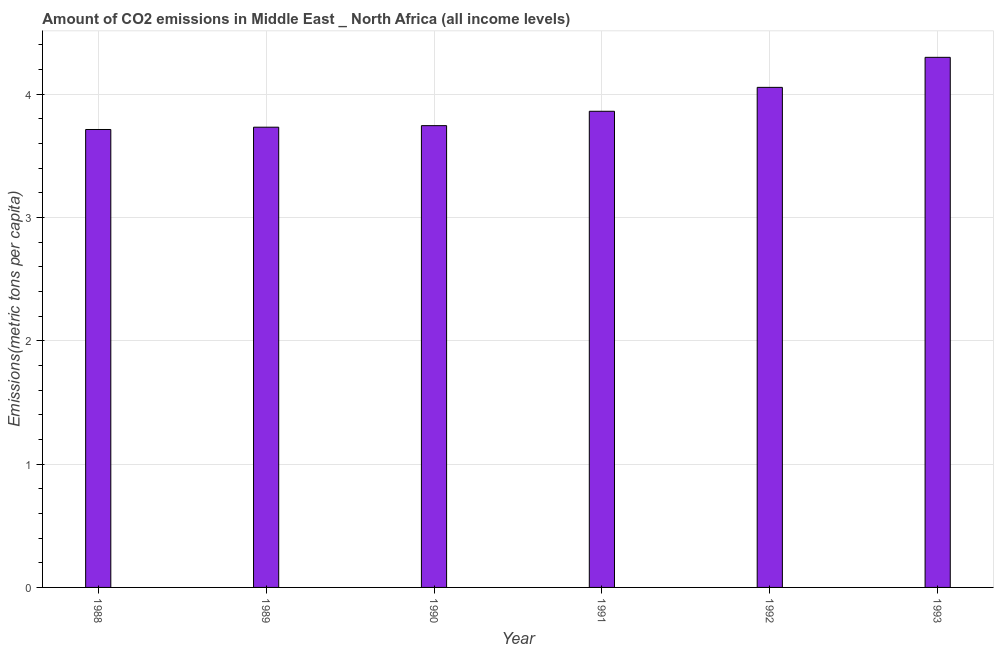Does the graph contain any zero values?
Your answer should be compact. No. Does the graph contain grids?
Make the answer very short. Yes. What is the title of the graph?
Provide a succinct answer. Amount of CO2 emissions in Middle East _ North Africa (all income levels). What is the label or title of the Y-axis?
Provide a succinct answer. Emissions(metric tons per capita). What is the amount of co2 emissions in 1990?
Provide a short and direct response. 3.74. Across all years, what is the maximum amount of co2 emissions?
Ensure brevity in your answer.  4.3. Across all years, what is the minimum amount of co2 emissions?
Offer a terse response. 3.71. What is the sum of the amount of co2 emissions?
Ensure brevity in your answer.  23.4. What is the difference between the amount of co2 emissions in 1988 and 1991?
Make the answer very short. -0.15. What is the average amount of co2 emissions per year?
Give a very brief answer. 3.9. What is the median amount of co2 emissions?
Your answer should be very brief. 3.8. In how many years, is the amount of co2 emissions greater than 1.8 metric tons per capita?
Offer a very short reply. 6. Do a majority of the years between 1990 and 1992 (inclusive) have amount of co2 emissions greater than 4 metric tons per capita?
Give a very brief answer. No. What is the ratio of the amount of co2 emissions in 1989 to that in 1991?
Give a very brief answer. 0.97. Is the amount of co2 emissions in 1988 less than that in 1989?
Ensure brevity in your answer.  Yes. What is the difference between the highest and the second highest amount of co2 emissions?
Make the answer very short. 0.24. What is the difference between the highest and the lowest amount of co2 emissions?
Ensure brevity in your answer.  0.59. How many years are there in the graph?
Your answer should be very brief. 6. What is the difference between two consecutive major ticks on the Y-axis?
Make the answer very short. 1. Are the values on the major ticks of Y-axis written in scientific E-notation?
Your answer should be very brief. No. What is the Emissions(metric tons per capita) in 1988?
Ensure brevity in your answer.  3.71. What is the Emissions(metric tons per capita) of 1989?
Offer a very short reply. 3.73. What is the Emissions(metric tons per capita) of 1990?
Provide a short and direct response. 3.74. What is the Emissions(metric tons per capita) of 1991?
Your answer should be very brief. 3.86. What is the Emissions(metric tons per capita) of 1992?
Your answer should be compact. 4.05. What is the Emissions(metric tons per capita) of 1993?
Your response must be concise. 4.3. What is the difference between the Emissions(metric tons per capita) in 1988 and 1989?
Your answer should be compact. -0.02. What is the difference between the Emissions(metric tons per capita) in 1988 and 1990?
Provide a short and direct response. -0.03. What is the difference between the Emissions(metric tons per capita) in 1988 and 1991?
Ensure brevity in your answer.  -0.15. What is the difference between the Emissions(metric tons per capita) in 1988 and 1992?
Your response must be concise. -0.34. What is the difference between the Emissions(metric tons per capita) in 1988 and 1993?
Provide a short and direct response. -0.59. What is the difference between the Emissions(metric tons per capita) in 1989 and 1990?
Make the answer very short. -0.01. What is the difference between the Emissions(metric tons per capita) in 1989 and 1991?
Ensure brevity in your answer.  -0.13. What is the difference between the Emissions(metric tons per capita) in 1989 and 1992?
Your answer should be very brief. -0.32. What is the difference between the Emissions(metric tons per capita) in 1989 and 1993?
Provide a succinct answer. -0.57. What is the difference between the Emissions(metric tons per capita) in 1990 and 1991?
Your answer should be compact. -0.12. What is the difference between the Emissions(metric tons per capita) in 1990 and 1992?
Your response must be concise. -0.31. What is the difference between the Emissions(metric tons per capita) in 1990 and 1993?
Your answer should be very brief. -0.55. What is the difference between the Emissions(metric tons per capita) in 1991 and 1992?
Provide a succinct answer. -0.19. What is the difference between the Emissions(metric tons per capita) in 1991 and 1993?
Provide a short and direct response. -0.44. What is the difference between the Emissions(metric tons per capita) in 1992 and 1993?
Your answer should be very brief. -0.24. What is the ratio of the Emissions(metric tons per capita) in 1988 to that in 1989?
Your response must be concise. 0.99. What is the ratio of the Emissions(metric tons per capita) in 1988 to that in 1991?
Your response must be concise. 0.96. What is the ratio of the Emissions(metric tons per capita) in 1988 to that in 1992?
Provide a succinct answer. 0.92. What is the ratio of the Emissions(metric tons per capita) in 1988 to that in 1993?
Offer a terse response. 0.86. What is the ratio of the Emissions(metric tons per capita) in 1989 to that in 1990?
Give a very brief answer. 1. What is the ratio of the Emissions(metric tons per capita) in 1989 to that in 1992?
Your response must be concise. 0.92. What is the ratio of the Emissions(metric tons per capita) in 1989 to that in 1993?
Your response must be concise. 0.87. What is the ratio of the Emissions(metric tons per capita) in 1990 to that in 1992?
Your response must be concise. 0.92. What is the ratio of the Emissions(metric tons per capita) in 1990 to that in 1993?
Give a very brief answer. 0.87. What is the ratio of the Emissions(metric tons per capita) in 1991 to that in 1992?
Your answer should be compact. 0.95. What is the ratio of the Emissions(metric tons per capita) in 1991 to that in 1993?
Provide a short and direct response. 0.9. What is the ratio of the Emissions(metric tons per capita) in 1992 to that in 1993?
Your answer should be very brief. 0.94. 